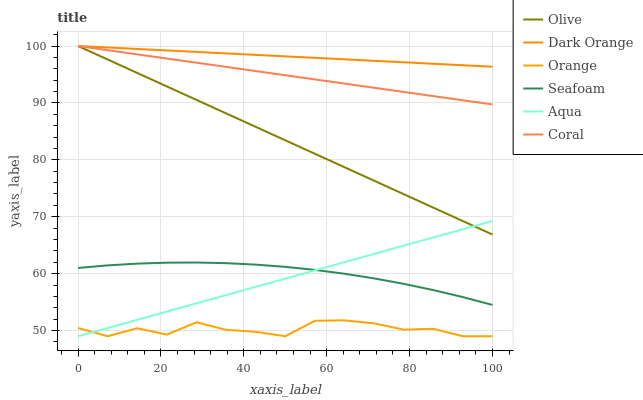Does Coral have the minimum area under the curve?
Answer yes or no. No. Does Coral have the maximum area under the curve?
Answer yes or no. No. Is Aqua the smoothest?
Answer yes or no. No. Is Aqua the roughest?
Answer yes or no. No. Does Coral have the lowest value?
Answer yes or no. No. Does Aqua have the highest value?
Answer yes or no. No. Is Seafoam less than Olive?
Answer yes or no. Yes. Is Coral greater than Seafoam?
Answer yes or no. Yes. Does Seafoam intersect Olive?
Answer yes or no. No. 